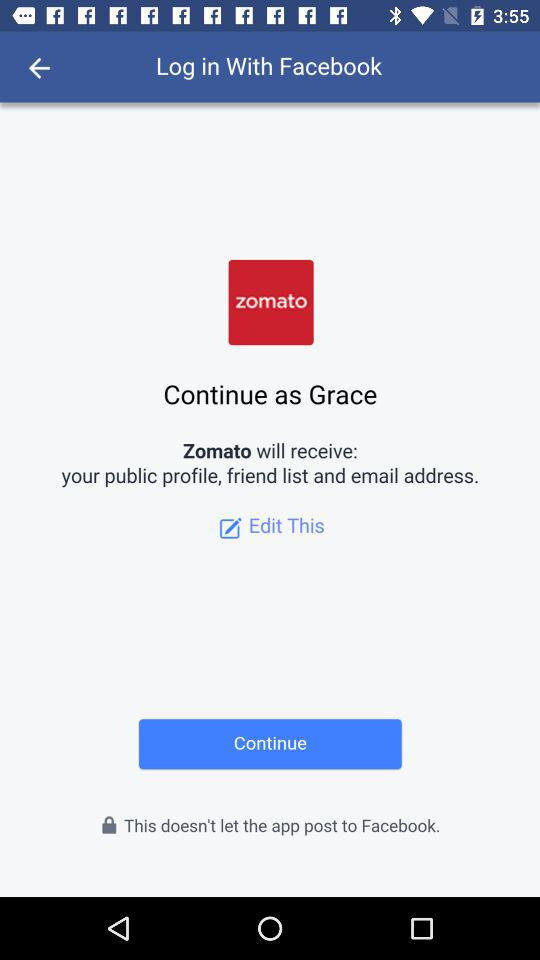What is the login name? The login name is Grace. 